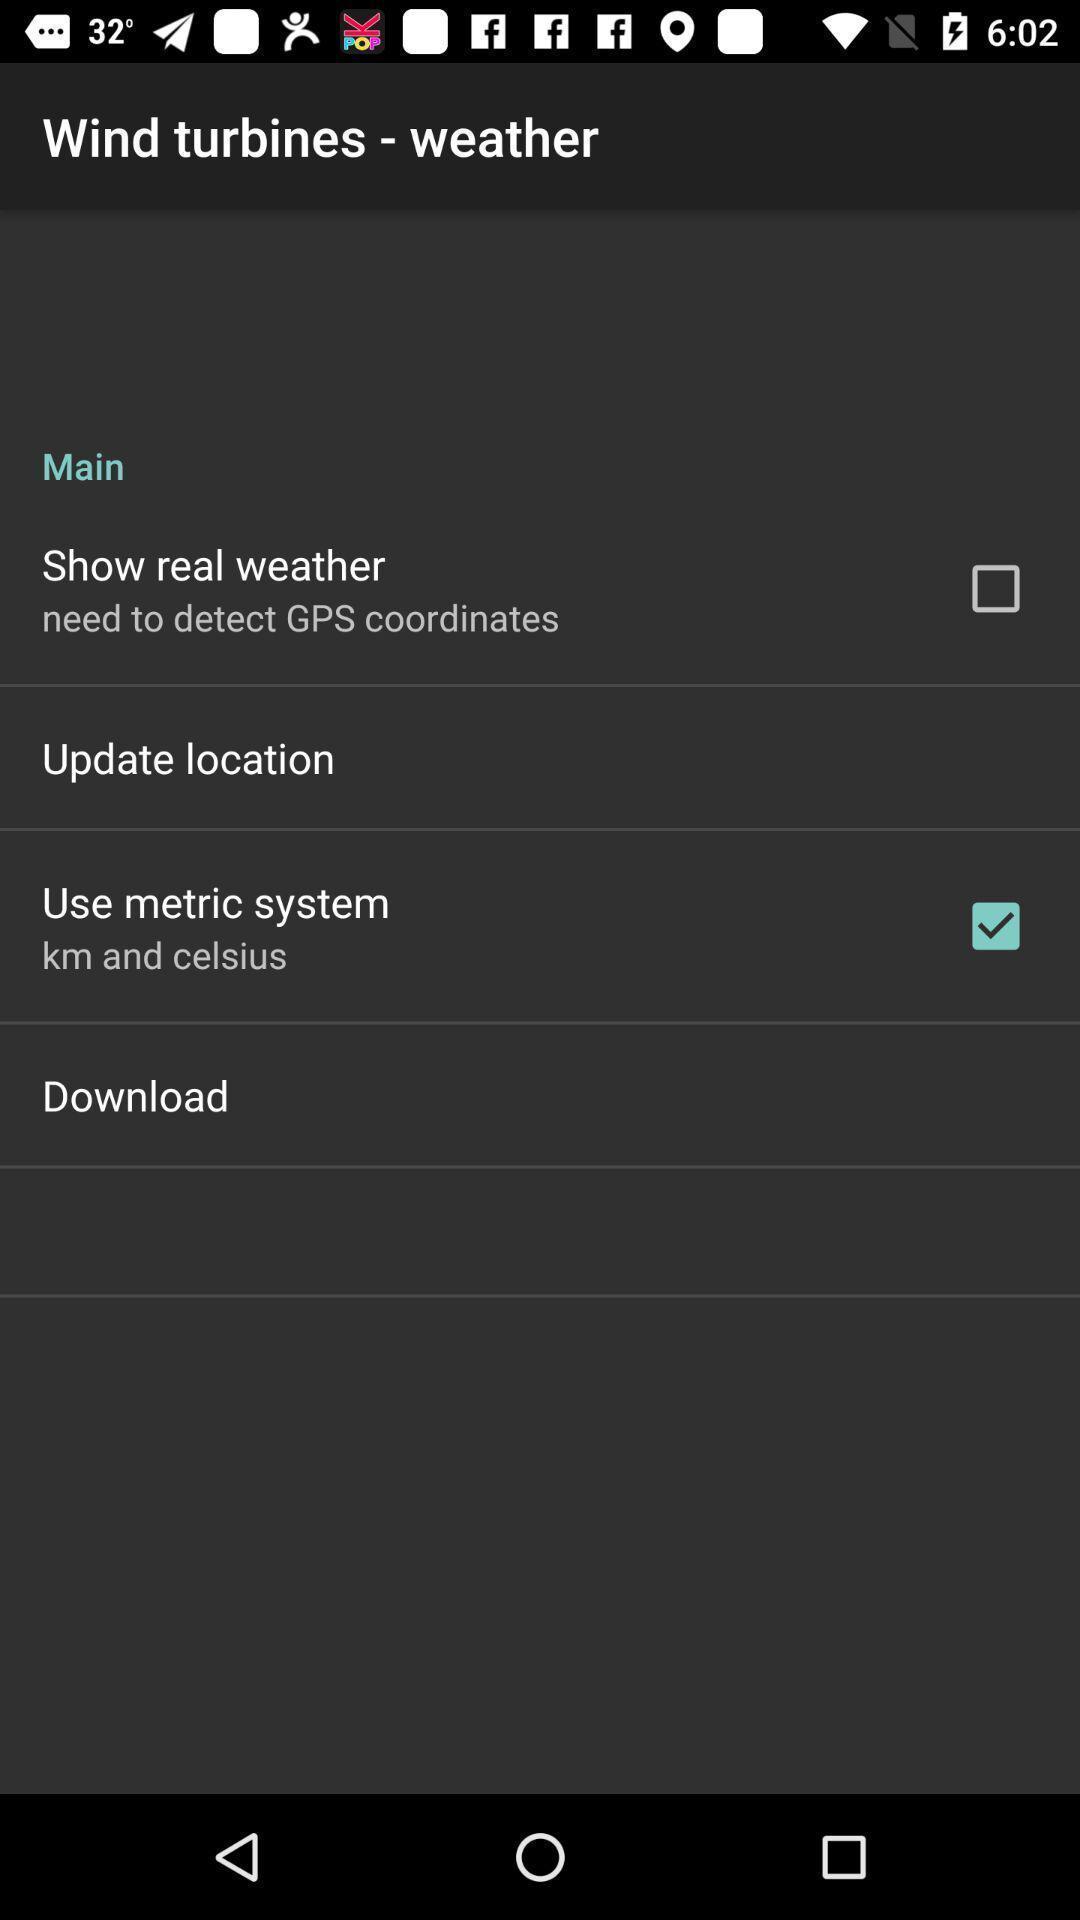Describe the key features of this screenshot. Settings page displayed of an weather application. 